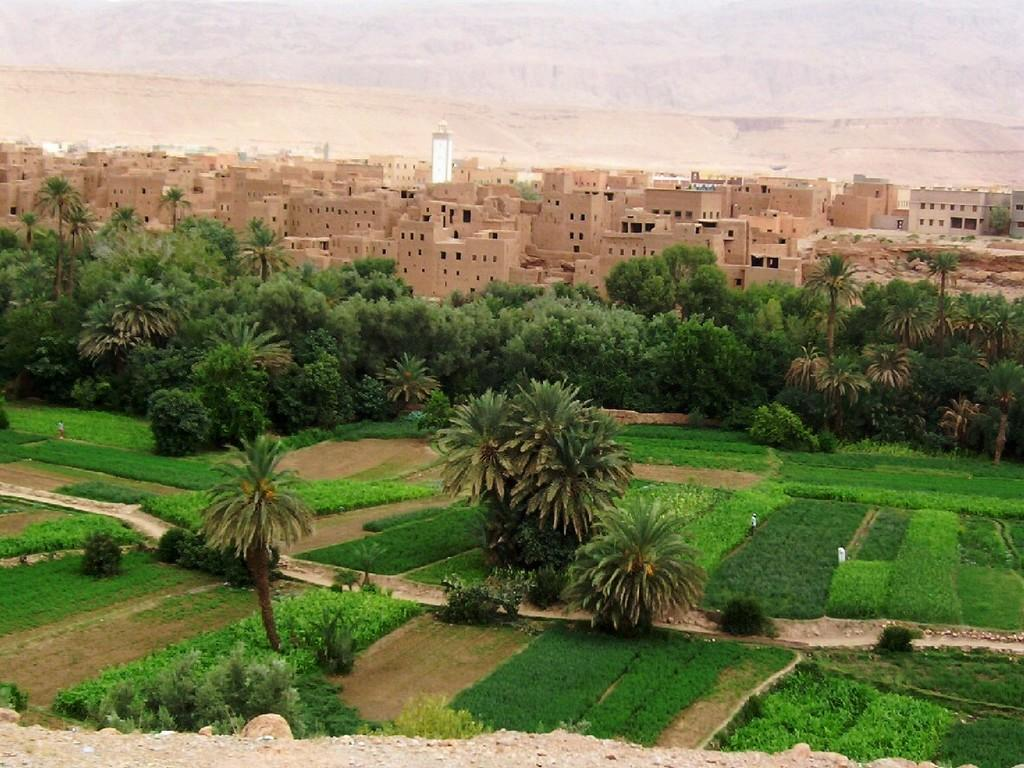What type of vegetation is present in the image? There is green grass, trees, and plants in the image. What can be seen in the background of the image? There are buildings and a tower visible in the background of the image. What type of poisonous plant can be seen in the image? There is no poisonous plant present in the image. What instrument is the drummer playing in the background of the image? There is no drummer or drum present in the image. 